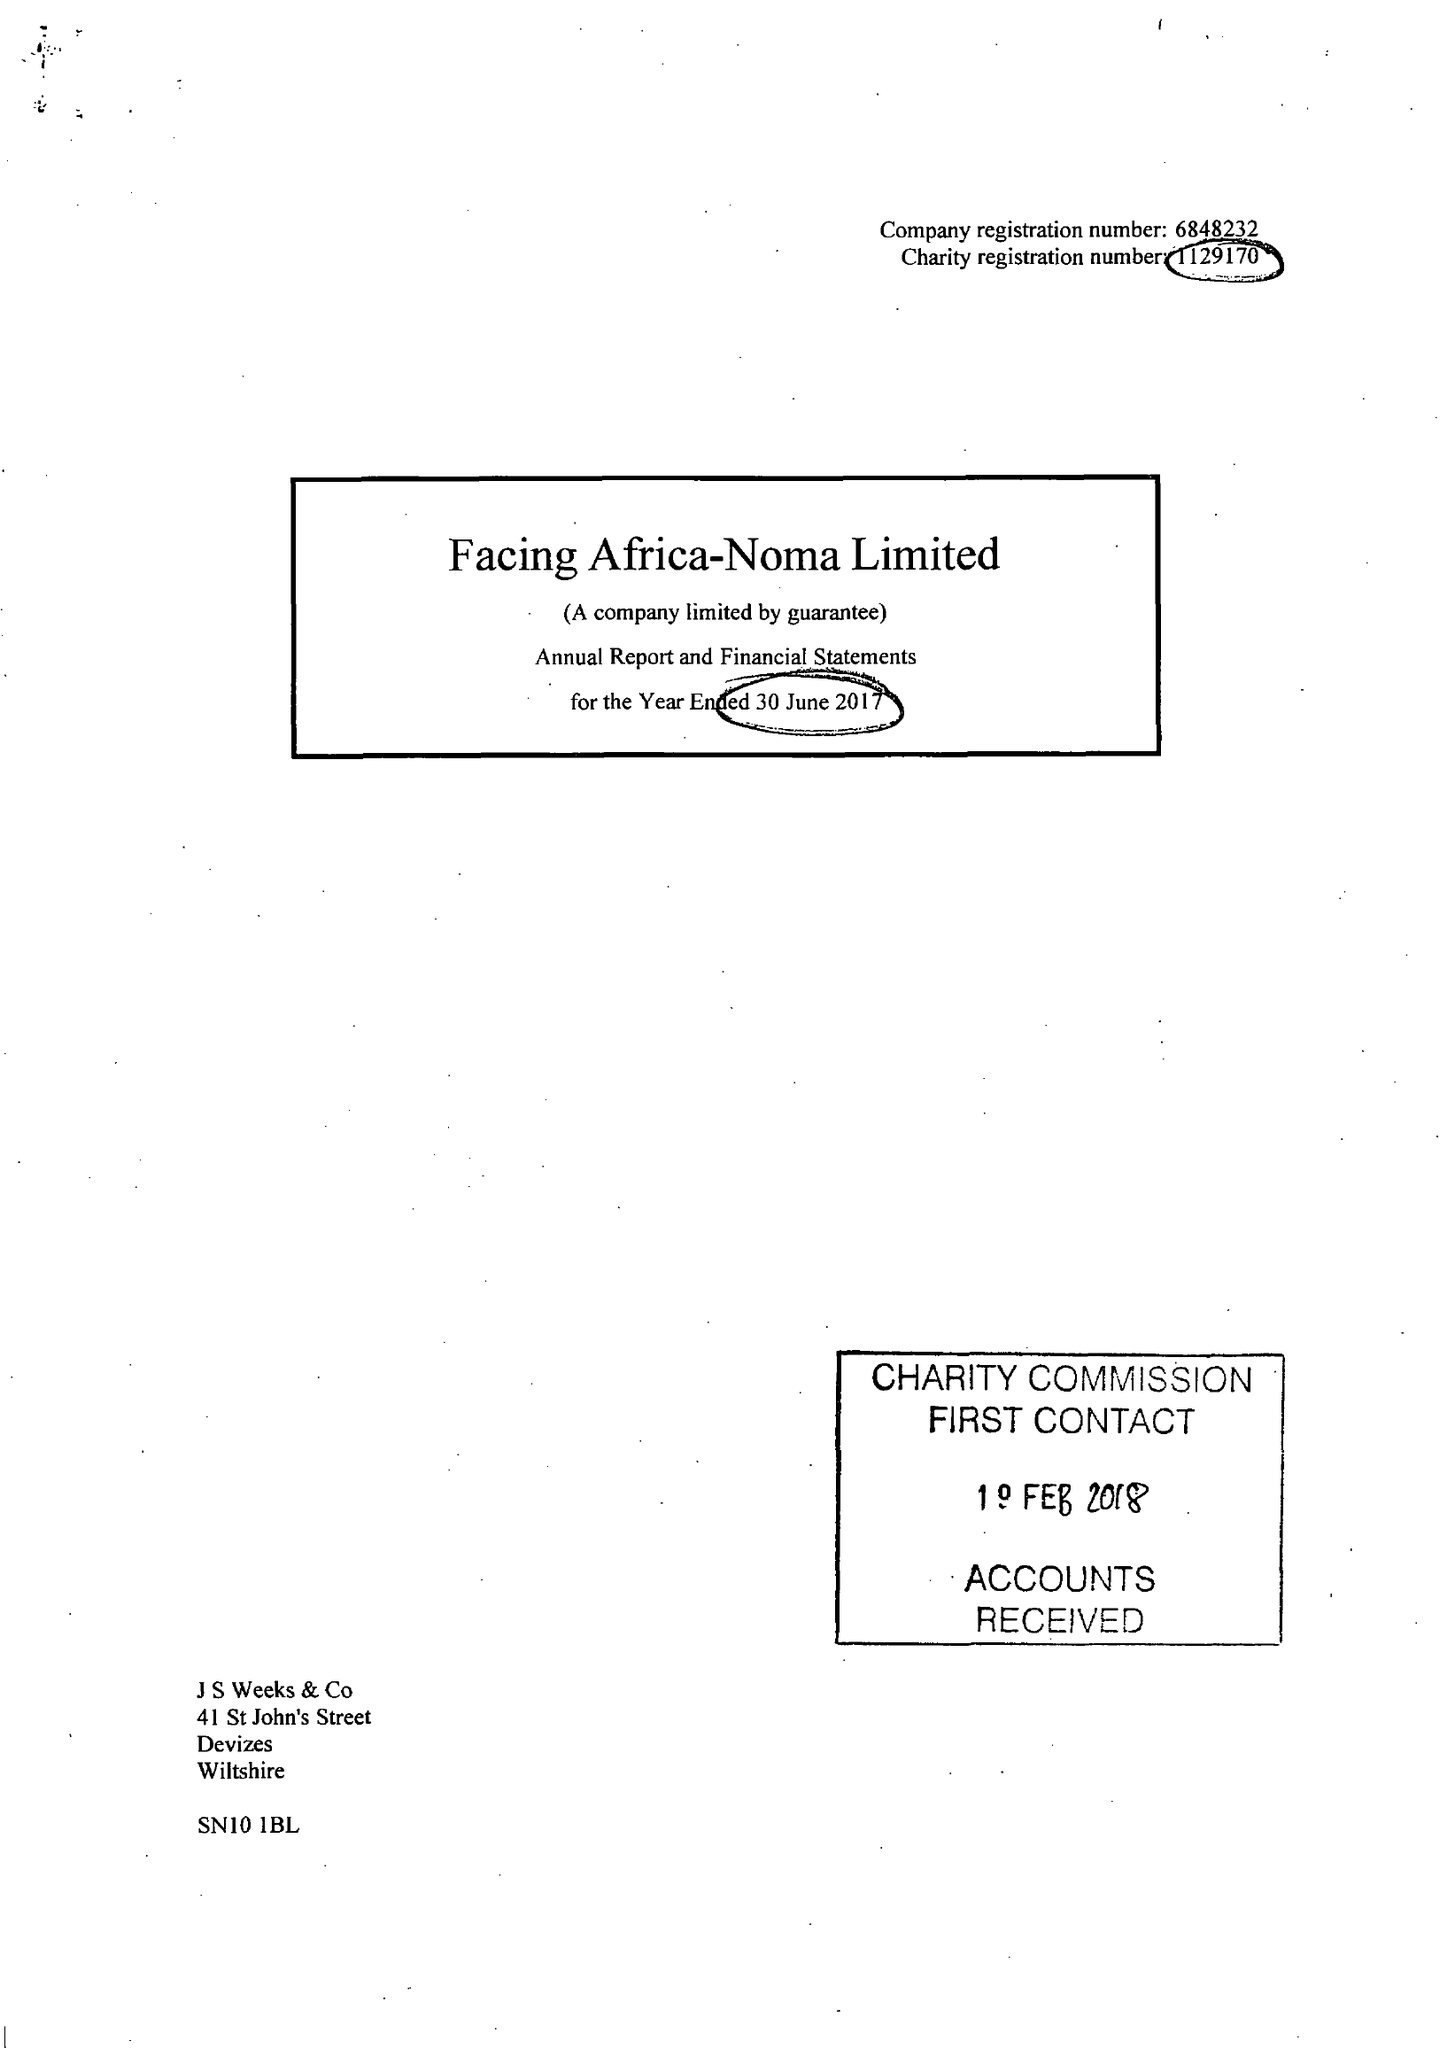What is the value for the address__post_town?
Answer the question using a single word or phrase. DEVIZES 